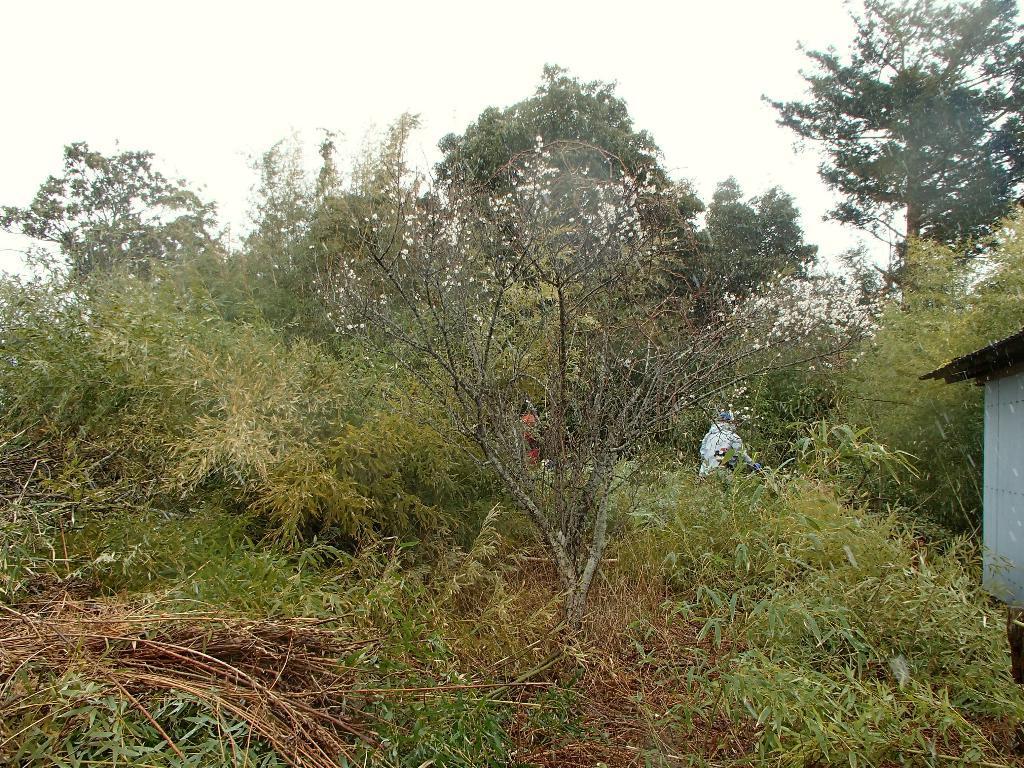Describe this image in one or two sentences. In this image we can see many trees and plants. We can see the sky in the image. There is a shed at the right side of the image. There are few people in the image. 